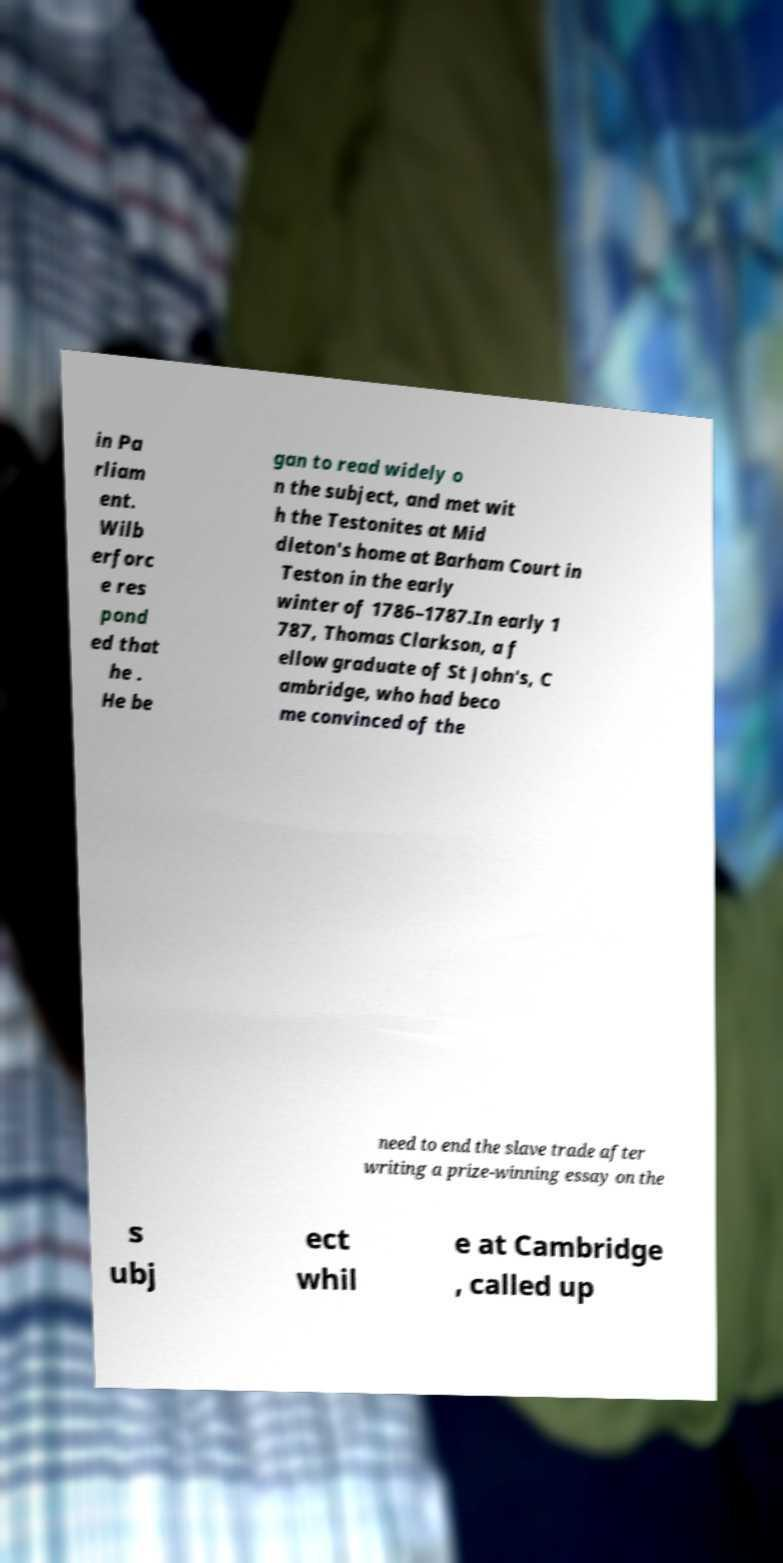For documentation purposes, I need the text within this image transcribed. Could you provide that? in Pa rliam ent. Wilb erforc e res pond ed that he . He be gan to read widely o n the subject, and met wit h the Testonites at Mid dleton's home at Barham Court in Teston in the early winter of 1786–1787.In early 1 787, Thomas Clarkson, a f ellow graduate of St John's, C ambridge, who had beco me convinced of the need to end the slave trade after writing a prize-winning essay on the s ubj ect whil e at Cambridge , called up 